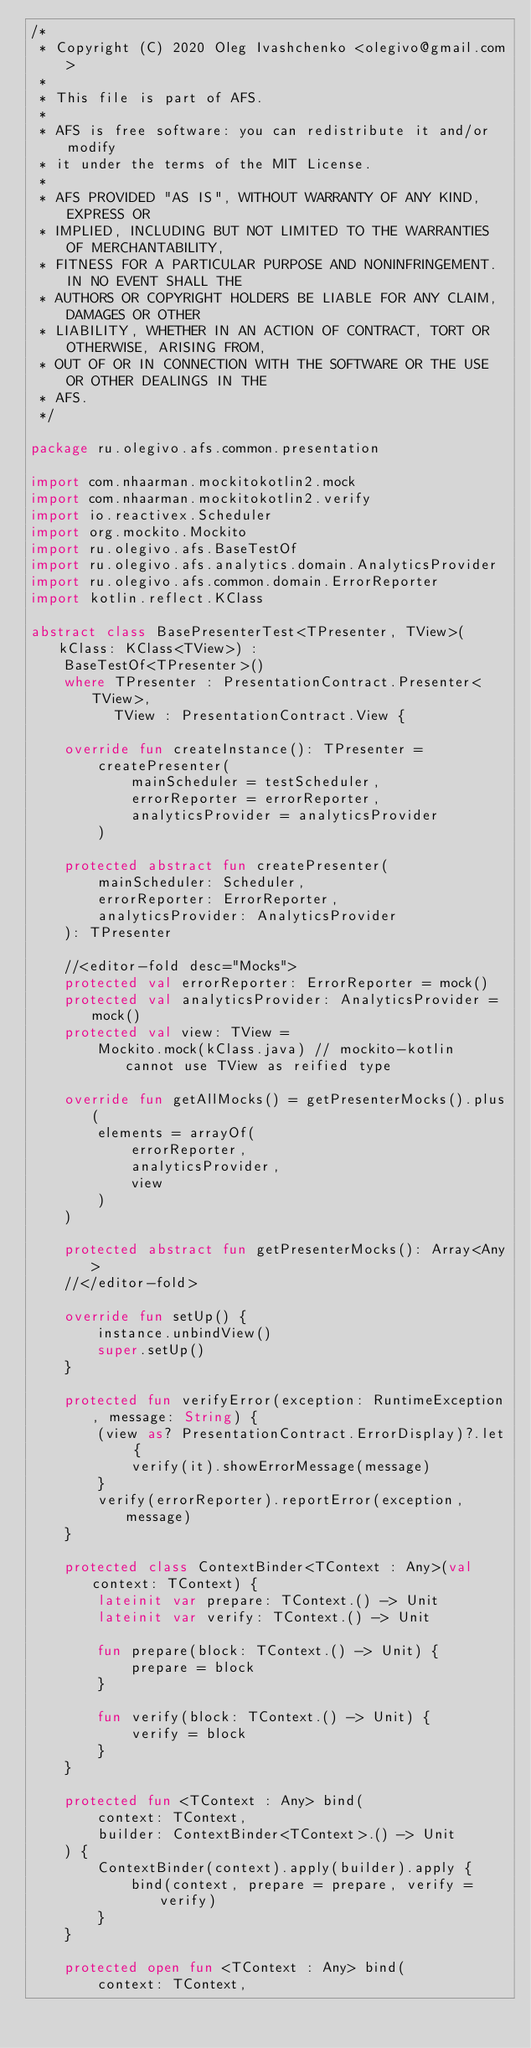<code> <loc_0><loc_0><loc_500><loc_500><_Kotlin_>/*
 * Copyright (C) 2020 Oleg Ivashchenko <olegivo@gmail.com>
 *
 * This file is part of AFS.
 *
 * AFS is free software: you can redistribute it and/or modify
 * it under the terms of the MIT License.
 *
 * AFS PROVIDED "AS IS", WITHOUT WARRANTY OF ANY KIND, EXPRESS OR
 * IMPLIED, INCLUDING BUT NOT LIMITED TO THE WARRANTIES OF MERCHANTABILITY,
 * FITNESS FOR A PARTICULAR PURPOSE AND NONINFRINGEMENT. IN NO EVENT SHALL THE
 * AUTHORS OR COPYRIGHT HOLDERS BE LIABLE FOR ANY CLAIM, DAMAGES OR OTHER
 * LIABILITY, WHETHER IN AN ACTION OF CONTRACT, TORT OR OTHERWISE, ARISING FROM,
 * OUT OF OR IN CONNECTION WITH THE SOFTWARE OR THE USE OR OTHER DEALINGS IN THE
 * AFS.
 */

package ru.olegivo.afs.common.presentation

import com.nhaarman.mockitokotlin2.mock
import com.nhaarman.mockitokotlin2.verify
import io.reactivex.Scheduler
import org.mockito.Mockito
import ru.olegivo.afs.BaseTestOf
import ru.olegivo.afs.analytics.domain.AnalyticsProvider
import ru.olegivo.afs.common.domain.ErrorReporter
import kotlin.reflect.KClass

abstract class BasePresenterTest<TPresenter, TView>(kClass: KClass<TView>) :
    BaseTestOf<TPresenter>()
    where TPresenter : PresentationContract.Presenter<TView>,
          TView : PresentationContract.View {

    override fun createInstance(): TPresenter =
        createPresenter(
            mainScheduler = testScheduler,
            errorReporter = errorReporter,
            analyticsProvider = analyticsProvider
        )

    protected abstract fun createPresenter(
        mainScheduler: Scheduler,
        errorReporter: ErrorReporter,
        analyticsProvider: AnalyticsProvider
    ): TPresenter

    //<editor-fold desc="Mocks">
    protected val errorReporter: ErrorReporter = mock()
    protected val analyticsProvider: AnalyticsProvider = mock()
    protected val view: TView =
        Mockito.mock(kClass.java) // mockito-kotlin cannot use TView as reified type

    override fun getAllMocks() = getPresenterMocks().plus(
        elements = arrayOf(
            errorReporter,
            analyticsProvider,
            view
        )
    )

    protected abstract fun getPresenterMocks(): Array<Any>
    //</editor-fold>

    override fun setUp() {
        instance.unbindView()
        super.setUp()
    }

    protected fun verifyError(exception: RuntimeException, message: String) {
        (view as? PresentationContract.ErrorDisplay)?.let {
            verify(it).showErrorMessage(message)
        }
        verify(errorReporter).reportError(exception, message)
    }

    protected class ContextBinder<TContext : Any>(val context: TContext) {
        lateinit var prepare: TContext.() -> Unit
        lateinit var verify: TContext.() -> Unit

        fun prepare(block: TContext.() -> Unit) {
            prepare = block
        }

        fun verify(block: TContext.() -> Unit) {
            verify = block
        }
    }

    protected fun <TContext : Any> bind(
        context: TContext,
        builder: ContextBinder<TContext>.() -> Unit
    ) {
        ContextBinder(context).apply(builder).apply {
            bind(context, prepare = prepare, verify = verify)
        }
    }

    protected open fun <TContext : Any> bind(
        context: TContext,</code> 